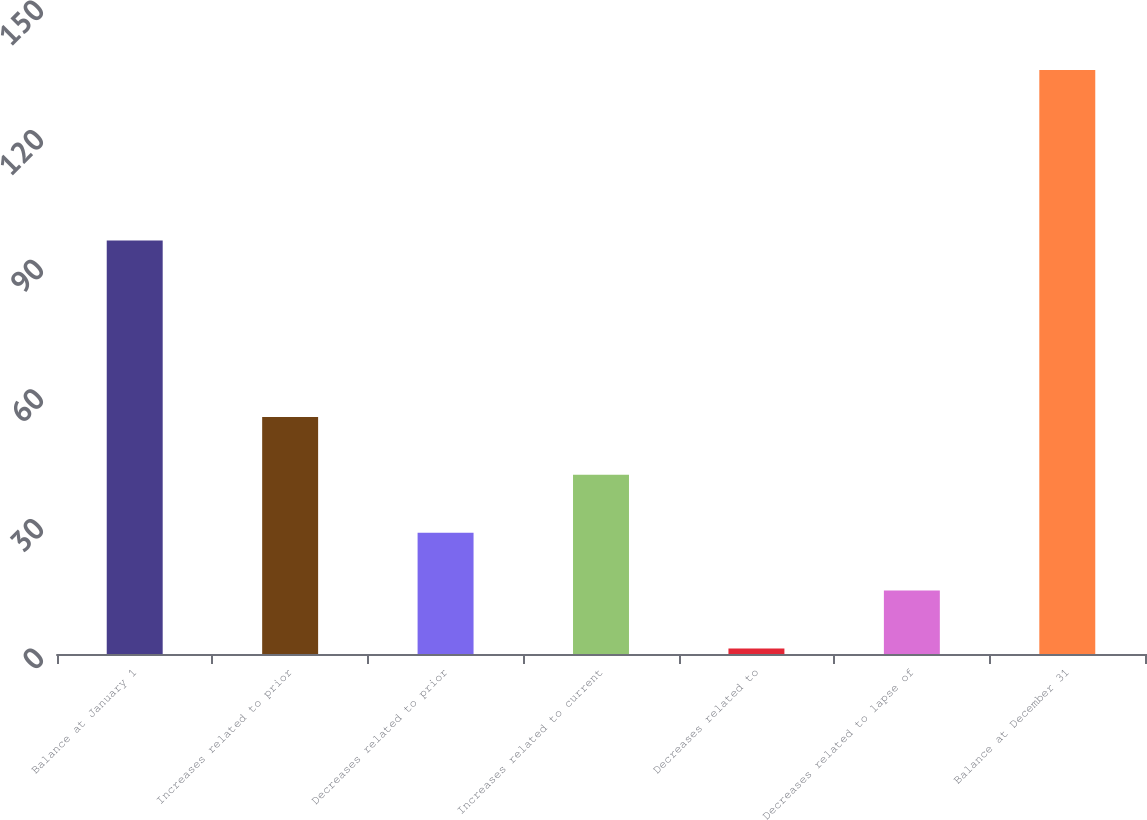Convert chart. <chart><loc_0><loc_0><loc_500><loc_500><bar_chart><fcel>Balance at January 1<fcel>Increases related to prior<fcel>Decreases related to prior<fcel>Increases related to current<fcel>Decreases related to<fcel>Decreases related to lapse of<fcel>Balance at December 31<nl><fcel>95.7<fcel>54.86<fcel>28.08<fcel>41.47<fcel>1.3<fcel>14.69<fcel>135.2<nl></chart> 